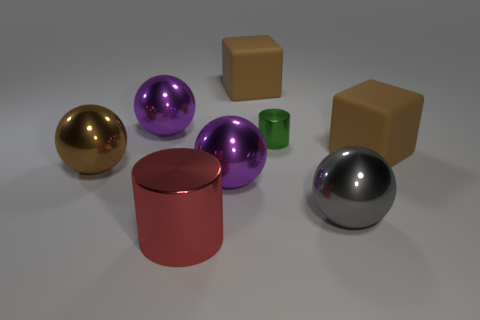Add 2 brown things. How many objects exist? 10 Subtract all large brown shiny balls. How many balls are left? 3 Subtract 4 balls. How many balls are left? 0 Subtract all gray balls. How many balls are left? 3 Subtract all blocks. How many objects are left? 6 Subtract all green cylinders. Subtract all green spheres. How many cylinders are left? 1 Subtract all green balls. How many red cylinders are left? 1 Subtract all cubes. Subtract all red metallic cylinders. How many objects are left? 5 Add 8 big red metal objects. How many big red metal objects are left? 9 Add 6 tiny shiny cylinders. How many tiny shiny cylinders exist? 7 